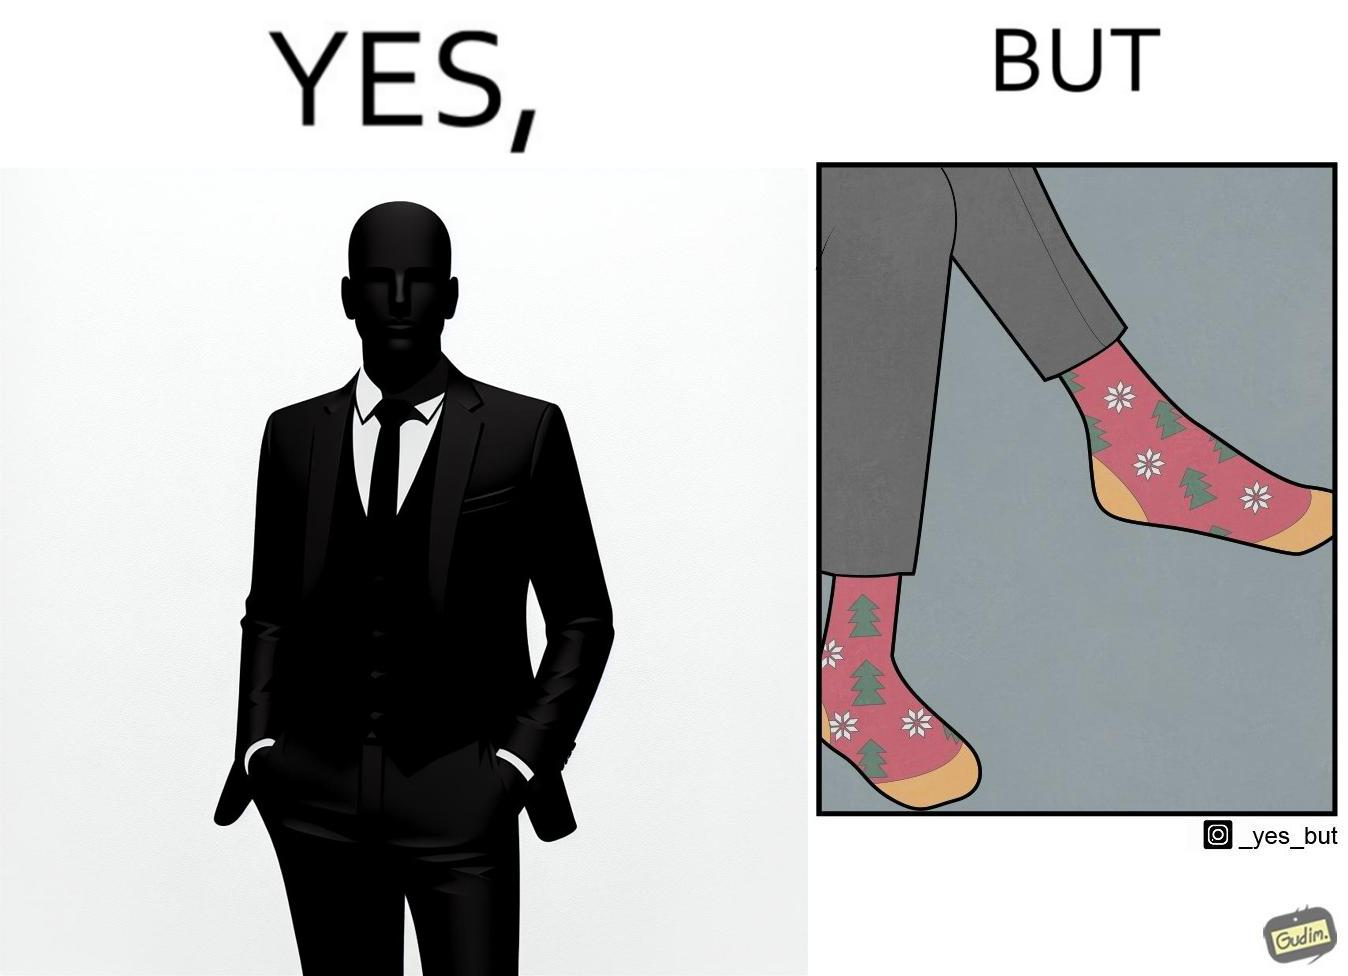What is the satirical meaning behind this image? The image is ironical, as the person wearing a formal black suit and pants, is wearing colorful socks, probably due to the reason that socks are not visible while wearing shoes, and hence, do not need to be formal. 